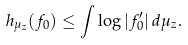<formula> <loc_0><loc_0><loc_500><loc_500>h _ { \mu _ { z } } ( f _ { 0 } ) \leq \int \log | f _ { 0 } ^ { \prime } | \, d \mu _ { z } .</formula> 